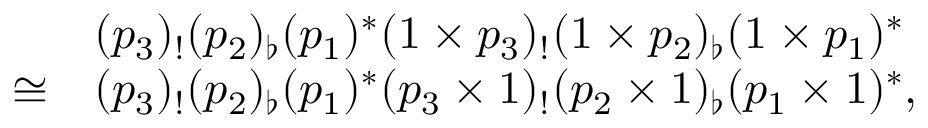Convert formula to latex. <formula><loc_0><loc_0><loc_500><loc_500>\begin{array} { r l } & { ( p _ { 3 } ) _ { ! } ( p _ { 2 } ) _ { \flat } ( p _ { 1 } ) ^ { * } ( 1 \times p _ { 3 } ) _ { ! } ( 1 \times p _ { 2 } ) _ { \flat } ( 1 \times p _ { 1 } ) ^ { * } } \\ { \cong } & { ( p _ { 3 } ) _ { ! } ( p _ { 2 } ) _ { \flat } ( p _ { 1 } ) ^ { * } ( p _ { 3 } \times 1 ) _ { ! } ( p _ { 2 } \times 1 ) _ { \flat } ( p _ { 1 } \times 1 ) ^ { * } , } \end{array}</formula> 